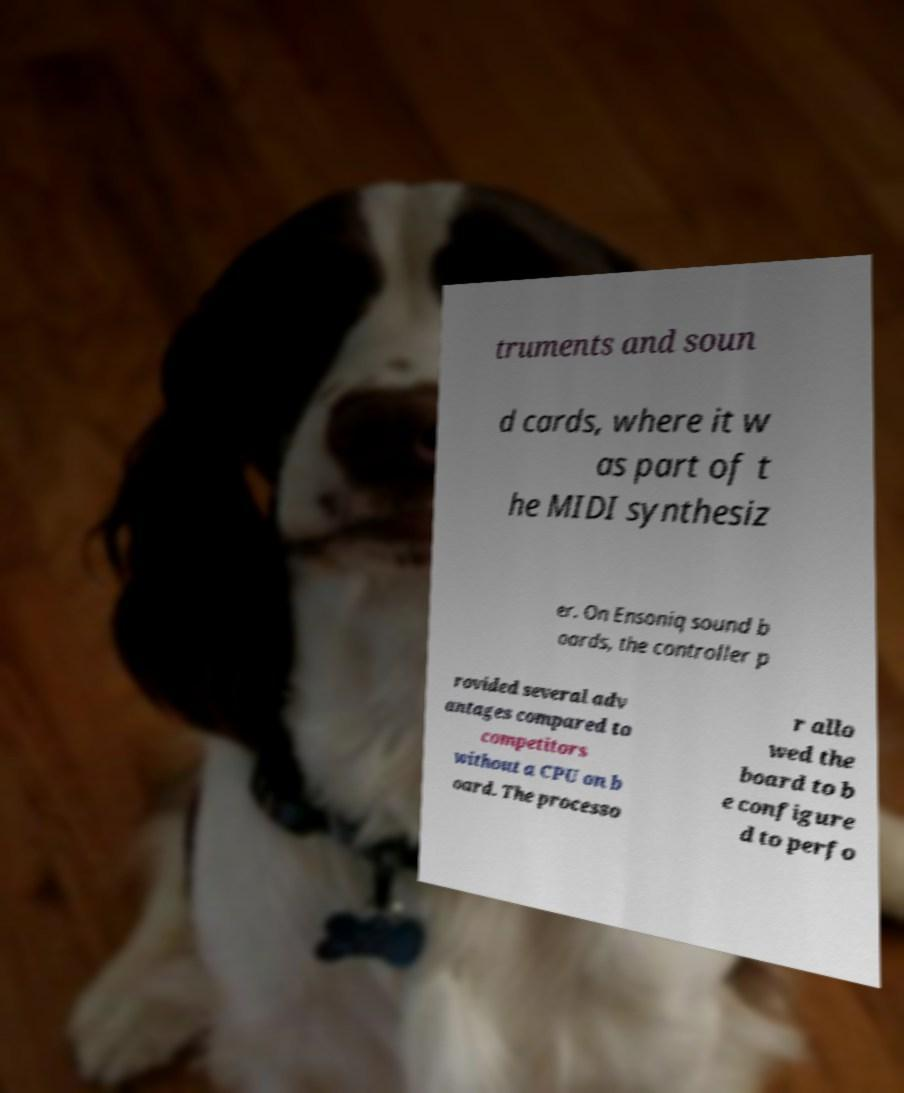Could you extract and type out the text from this image? truments and soun d cards, where it w as part of t he MIDI synthesiz er. On Ensoniq sound b oards, the controller p rovided several adv antages compared to competitors without a CPU on b oard. The processo r allo wed the board to b e configure d to perfo 